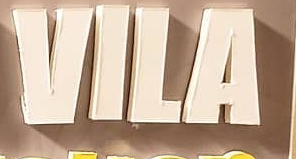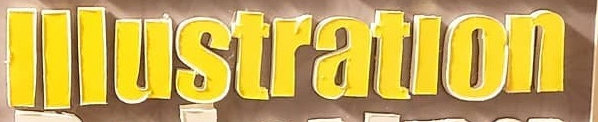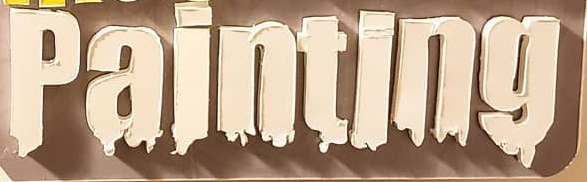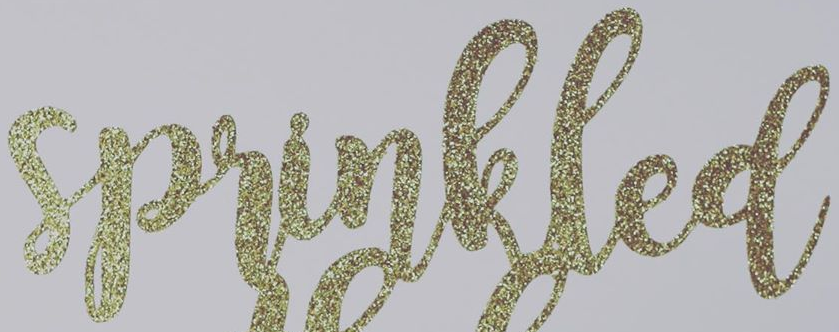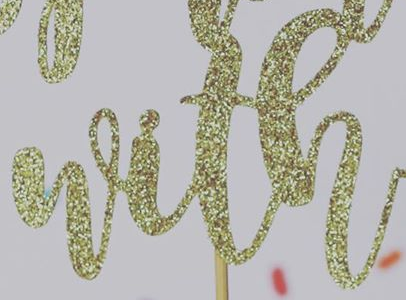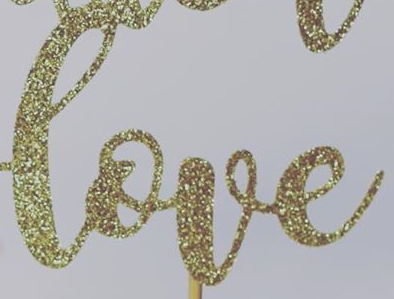Transcribe the words shown in these images in order, separated by a semicolon. VILA; lllustratlon; painting; sprinkled; with; love 